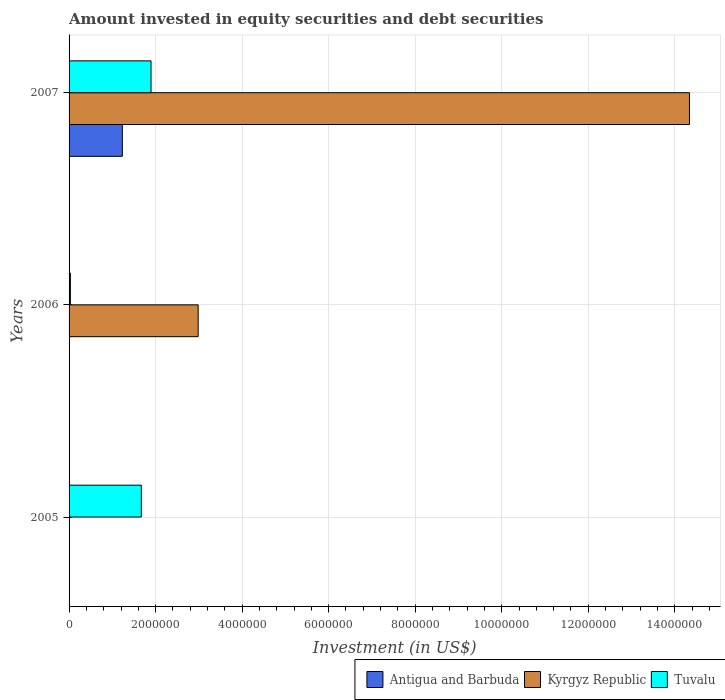How many different coloured bars are there?
Your answer should be compact. 3. Are the number of bars per tick equal to the number of legend labels?
Your answer should be compact. No. Are the number of bars on each tick of the Y-axis equal?
Keep it short and to the point. No. In how many cases, is the number of bars for a given year not equal to the number of legend labels?
Provide a succinct answer. 2. What is the amount invested in equity securities and debt securities in Kyrgyz Republic in 2007?
Ensure brevity in your answer.  1.43e+07. Across all years, what is the maximum amount invested in equity securities and debt securities in Antigua and Barbuda?
Your response must be concise. 1.23e+06. Across all years, what is the minimum amount invested in equity securities and debt securities in Tuvalu?
Make the answer very short. 3.05e+04. In which year was the amount invested in equity securities and debt securities in Tuvalu maximum?
Provide a succinct answer. 2007. What is the total amount invested in equity securities and debt securities in Tuvalu in the graph?
Give a very brief answer. 3.59e+06. What is the difference between the amount invested in equity securities and debt securities in Tuvalu in 2005 and that in 2006?
Provide a succinct answer. 1.64e+06. What is the difference between the amount invested in equity securities and debt securities in Antigua and Barbuda in 2005 and the amount invested in equity securities and debt securities in Kyrgyz Republic in 2007?
Provide a succinct answer. -1.43e+07. What is the average amount invested in equity securities and debt securities in Kyrgyz Republic per year?
Offer a very short reply. 5.77e+06. In the year 2007, what is the difference between the amount invested in equity securities and debt securities in Antigua and Barbuda and amount invested in equity securities and debt securities in Kyrgyz Republic?
Your response must be concise. -1.31e+07. In how many years, is the amount invested in equity securities and debt securities in Tuvalu greater than 14400000 US$?
Provide a short and direct response. 0. What is the ratio of the amount invested in equity securities and debt securities in Tuvalu in 2006 to that in 2007?
Your answer should be very brief. 0.02. What is the difference between the highest and the second highest amount invested in equity securities and debt securities in Tuvalu?
Your answer should be very brief. 2.25e+05. What is the difference between the highest and the lowest amount invested in equity securities and debt securities in Kyrgyz Republic?
Offer a terse response. 1.43e+07. How many bars are there?
Ensure brevity in your answer.  6. Are all the bars in the graph horizontal?
Your answer should be compact. Yes. How many years are there in the graph?
Provide a short and direct response. 3. Where does the legend appear in the graph?
Give a very brief answer. Bottom right. How many legend labels are there?
Your answer should be compact. 3. How are the legend labels stacked?
Your response must be concise. Horizontal. What is the title of the graph?
Give a very brief answer. Amount invested in equity securities and debt securities. What is the label or title of the X-axis?
Provide a succinct answer. Investment (in US$). What is the label or title of the Y-axis?
Make the answer very short. Years. What is the Investment (in US$) of Antigua and Barbuda in 2005?
Provide a succinct answer. 0. What is the Investment (in US$) in Tuvalu in 2005?
Offer a terse response. 1.67e+06. What is the Investment (in US$) of Antigua and Barbuda in 2006?
Your answer should be compact. 0. What is the Investment (in US$) in Kyrgyz Republic in 2006?
Give a very brief answer. 2.98e+06. What is the Investment (in US$) in Tuvalu in 2006?
Provide a short and direct response. 3.05e+04. What is the Investment (in US$) of Antigua and Barbuda in 2007?
Provide a short and direct response. 1.23e+06. What is the Investment (in US$) in Kyrgyz Republic in 2007?
Offer a very short reply. 1.43e+07. What is the Investment (in US$) of Tuvalu in 2007?
Give a very brief answer. 1.89e+06. Across all years, what is the maximum Investment (in US$) in Antigua and Barbuda?
Provide a succinct answer. 1.23e+06. Across all years, what is the maximum Investment (in US$) of Kyrgyz Republic?
Provide a short and direct response. 1.43e+07. Across all years, what is the maximum Investment (in US$) of Tuvalu?
Offer a very short reply. 1.89e+06. Across all years, what is the minimum Investment (in US$) of Tuvalu?
Offer a very short reply. 3.05e+04. What is the total Investment (in US$) in Antigua and Barbuda in the graph?
Offer a very short reply. 1.23e+06. What is the total Investment (in US$) of Kyrgyz Republic in the graph?
Your answer should be compact. 1.73e+07. What is the total Investment (in US$) of Tuvalu in the graph?
Give a very brief answer. 3.59e+06. What is the difference between the Investment (in US$) in Tuvalu in 2005 and that in 2006?
Give a very brief answer. 1.64e+06. What is the difference between the Investment (in US$) of Tuvalu in 2005 and that in 2007?
Provide a short and direct response. -2.25e+05. What is the difference between the Investment (in US$) of Kyrgyz Republic in 2006 and that in 2007?
Offer a terse response. -1.14e+07. What is the difference between the Investment (in US$) of Tuvalu in 2006 and that in 2007?
Your answer should be very brief. -1.86e+06. What is the difference between the Investment (in US$) in Kyrgyz Republic in 2006 and the Investment (in US$) in Tuvalu in 2007?
Keep it short and to the point. 1.09e+06. What is the average Investment (in US$) of Antigua and Barbuda per year?
Provide a succinct answer. 4.10e+05. What is the average Investment (in US$) in Kyrgyz Republic per year?
Ensure brevity in your answer.  5.77e+06. What is the average Investment (in US$) of Tuvalu per year?
Offer a very short reply. 1.20e+06. In the year 2006, what is the difference between the Investment (in US$) of Kyrgyz Republic and Investment (in US$) of Tuvalu?
Keep it short and to the point. 2.95e+06. In the year 2007, what is the difference between the Investment (in US$) of Antigua and Barbuda and Investment (in US$) of Kyrgyz Republic?
Provide a succinct answer. -1.31e+07. In the year 2007, what is the difference between the Investment (in US$) in Antigua and Barbuda and Investment (in US$) in Tuvalu?
Your answer should be compact. -6.63e+05. In the year 2007, what is the difference between the Investment (in US$) of Kyrgyz Republic and Investment (in US$) of Tuvalu?
Offer a terse response. 1.24e+07. What is the ratio of the Investment (in US$) of Tuvalu in 2005 to that in 2006?
Your answer should be very brief. 54.82. What is the ratio of the Investment (in US$) of Tuvalu in 2005 to that in 2007?
Offer a terse response. 0.88. What is the ratio of the Investment (in US$) of Kyrgyz Republic in 2006 to that in 2007?
Provide a succinct answer. 0.21. What is the ratio of the Investment (in US$) in Tuvalu in 2006 to that in 2007?
Keep it short and to the point. 0.02. What is the difference between the highest and the second highest Investment (in US$) of Tuvalu?
Offer a very short reply. 2.25e+05. What is the difference between the highest and the lowest Investment (in US$) in Antigua and Barbuda?
Ensure brevity in your answer.  1.23e+06. What is the difference between the highest and the lowest Investment (in US$) of Kyrgyz Republic?
Your answer should be compact. 1.43e+07. What is the difference between the highest and the lowest Investment (in US$) of Tuvalu?
Your answer should be compact. 1.86e+06. 